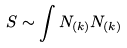Convert formula to latex. <formula><loc_0><loc_0><loc_500><loc_500>S \sim \int N _ { ( k ) } N _ { ( k ) }</formula> 